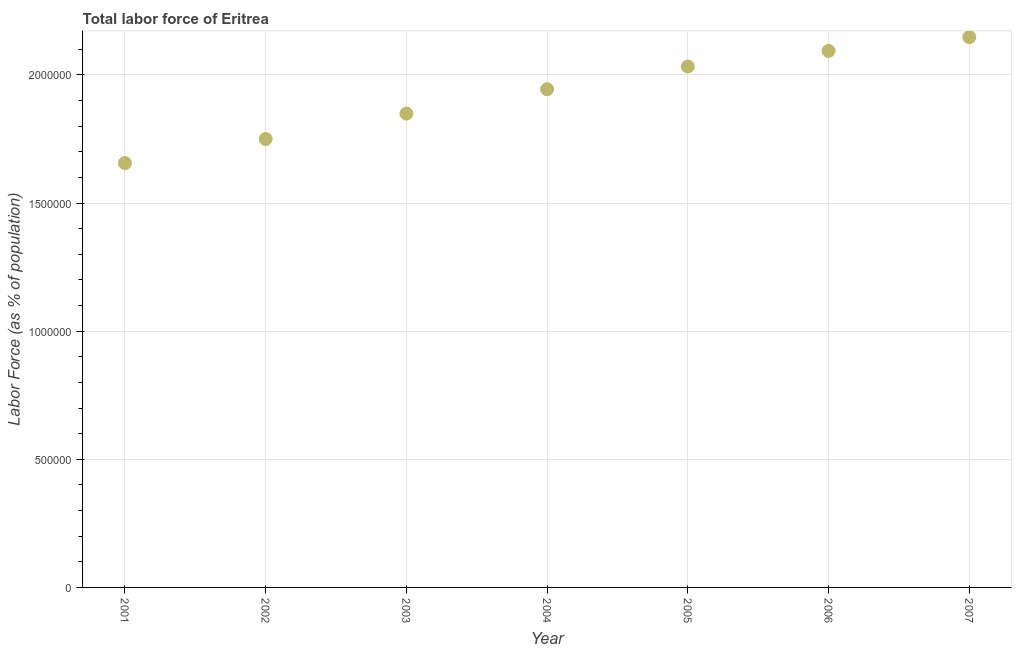What is the total labor force in 2002?
Your answer should be very brief. 1.75e+06. Across all years, what is the maximum total labor force?
Offer a very short reply. 2.15e+06. Across all years, what is the minimum total labor force?
Ensure brevity in your answer.  1.66e+06. What is the sum of the total labor force?
Provide a short and direct response. 1.35e+07. What is the difference between the total labor force in 2001 and 2004?
Make the answer very short. -2.88e+05. What is the average total labor force per year?
Offer a terse response. 1.92e+06. What is the median total labor force?
Provide a short and direct response. 1.94e+06. In how many years, is the total labor force greater than 1100000 %?
Ensure brevity in your answer.  7. Do a majority of the years between 2005 and 2006 (inclusive) have total labor force greater than 500000 %?
Provide a succinct answer. Yes. What is the ratio of the total labor force in 2001 to that in 2006?
Provide a succinct answer. 0.79. Is the total labor force in 2005 less than that in 2007?
Your answer should be very brief. Yes. What is the difference between the highest and the second highest total labor force?
Your answer should be very brief. 5.38e+04. What is the difference between the highest and the lowest total labor force?
Provide a short and direct response. 4.92e+05. Does the total labor force monotonically increase over the years?
Make the answer very short. Yes. What is the difference between two consecutive major ticks on the Y-axis?
Give a very brief answer. 5.00e+05. Are the values on the major ticks of Y-axis written in scientific E-notation?
Give a very brief answer. No. Does the graph contain any zero values?
Offer a terse response. No. Does the graph contain grids?
Ensure brevity in your answer.  Yes. What is the title of the graph?
Your response must be concise. Total labor force of Eritrea. What is the label or title of the X-axis?
Your response must be concise. Year. What is the label or title of the Y-axis?
Ensure brevity in your answer.  Labor Force (as % of population). What is the Labor Force (as % of population) in 2001?
Provide a short and direct response. 1.66e+06. What is the Labor Force (as % of population) in 2002?
Make the answer very short. 1.75e+06. What is the Labor Force (as % of population) in 2003?
Offer a very short reply. 1.85e+06. What is the Labor Force (as % of population) in 2004?
Offer a terse response. 1.94e+06. What is the Labor Force (as % of population) in 2005?
Your answer should be very brief. 2.03e+06. What is the Labor Force (as % of population) in 2006?
Ensure brevity in your answer.  2.09e+06. What is the Labor Force (as % of population) in 2007?
Offer a terse response. 2.15e+06. What is the difference between the Labor Force (as % of population) in 2001 and 2002?
Your answer should be very brief. -9.39e+04. What is the difference between the Labor Force (as % of population) in 2001 and 2003?
Provide a succinct answer. -1.93e+05. What is the difference between the Labor Force (as % of population) in 2001 and 2004?
Your response must be concise. -2.88e+05. What is the difference between the Labor Force (as % of population) in 2001 and 2005?
Keep it short and to the point. -3.77e+05. What is the difference between the Labor Force (as % of population) in 2001 and 2006?
Your response must be concise. -4.38e+05. What is the difference between the Labor Force (as % of population) in 2001 and 2007?
Your response must be concise. -4.92e+05. What is the difference between the Labor Force (as % of population) in 2002 and 2003?
Offer a terse response. -9.93e+04. What is the difference between the Labor Force (as % of population) in 2002 and 2004?
Provide a short and direct response. -1.94e+05. What is the difference between the Labor Force (as % of population) in 2002 and 2005?
Provide a succinct answer. -2.83e+05. What is the difference between the Labor Force (as % of population) in 2002 and 2006?
Give a very brief answer. -3.44e+05. What is the difference between the Labor Force (as % of population) in 2002 and 2007?
Your answer should be compact. -3.98e+05. What is the difference between the Labor Force (as % of population) in 2003 and 2004?
Your answer should be compact. -9.50e+04. What is the difference between the Labor Force (as % of population) in 2003 and 2005?
Provide a short and direct response. -1.84e+05. What is the difference between the Labor Force (as % of population) in 2003 and 2006?
Your answer should be compact. -2.45e+05. What is the difference between the Labor Force (as % of population) in 2003 and 2007?
Ensure brevity in your answer.  -2.98e+05. What is the difference between the Labor Force (as % of population) in 2004 and 2005?
Offer a very short reply. -8.88e+04. What is the difference between the Labor Force (as % of population) in 2004 and 2006?
Provide a short and direct response. -1.50e+05. What is the difference between the Labor Force (as % of population) in 2004 and 2007?
Offer a very short reply. -2.03e+05. What is the difference between the Labor Force (as % of population) in 2005 and 2006?
Offer a terse response. -6.08e+04. What is the difference between the Labor Force (as % of population) in 2005 and 2007?
Offer a terse response. -1.15e+05. What is the difference between the Labor Force (as % of population) in 2006 and 2007?
Offer a terse response. -5.38e+04. What is the ratio of the Labor Force (as % of population) in 2001 to that in 2002?
Make the answer very short. 0.95. What is the ratio of the Labor Force (as % of population) in 2001 to that in 2003?
Make the answer very short. 0.9. What is the ratio of the Labor Force (as % of population) in 2001 to that in 2004?
Your answer should be very brief. 0.85. What is the ratio of the Labor Force (as % of population) in 2001 to that in 2005?
Your answer should be compact. 0.81. What is the ratio of the Labor Force (as % of population) in 2001 to that in 2006?
Offer a very short reply. 0.79. What is the ratio of the Labor Force (as % of population) in 2001 to that in 2007?
Offer a very short reply. 0.77. What is the ratio of the Labor Force (as % of population) in 2002 to that in 2003?
Ensure brevity in your answer.  0.95. What is the ratio of the Labor Force (as % of population) in 2002 to that in 2005?
Your answer should be compact. 0.86. What is the ratio of the Labor Force (as % of population) in 2002 to that in 2006?
Ensure brevity in your answer.  0.84. What is the ratio of the Labor Force (as % of population) in 2002 to that in 2007?
Give a very brief answer. 0.81. What is the ratio of the Labor Force (as % of population) in 2003 to that in 2004?
Ensure brevity in your answer.  0.95. What is the ratio of the Labor Force (as % of population) in 2003 to that in 2005?
Your answer should be very brief. 0.91. What is the ratio of the Labor Force (as % of population) in 2003 to that in 2006?
Give a very brief answer. 0.88. What is the ratio of the Labor Force (as % of population) in 2003 to that in 2007?
Your response must be concise. 0.86. What is the ratio of the Labor Force (as % of population) in 2004 to that in 2005?
Give a very brief answer. 0.96. What is the ratio of the Labor Force (as % of population) in 2004 to that in 2006?
Your answer should be compact. 0.93. What is the ratio of the Labor Force (as % of population) in 2004 to that in 2007?
Your response must be concise. 0.91. What is the ratio of the Labor Force (as % of population) in 2005 to that in 2007?
Provide a short and direct response. 0.95. 